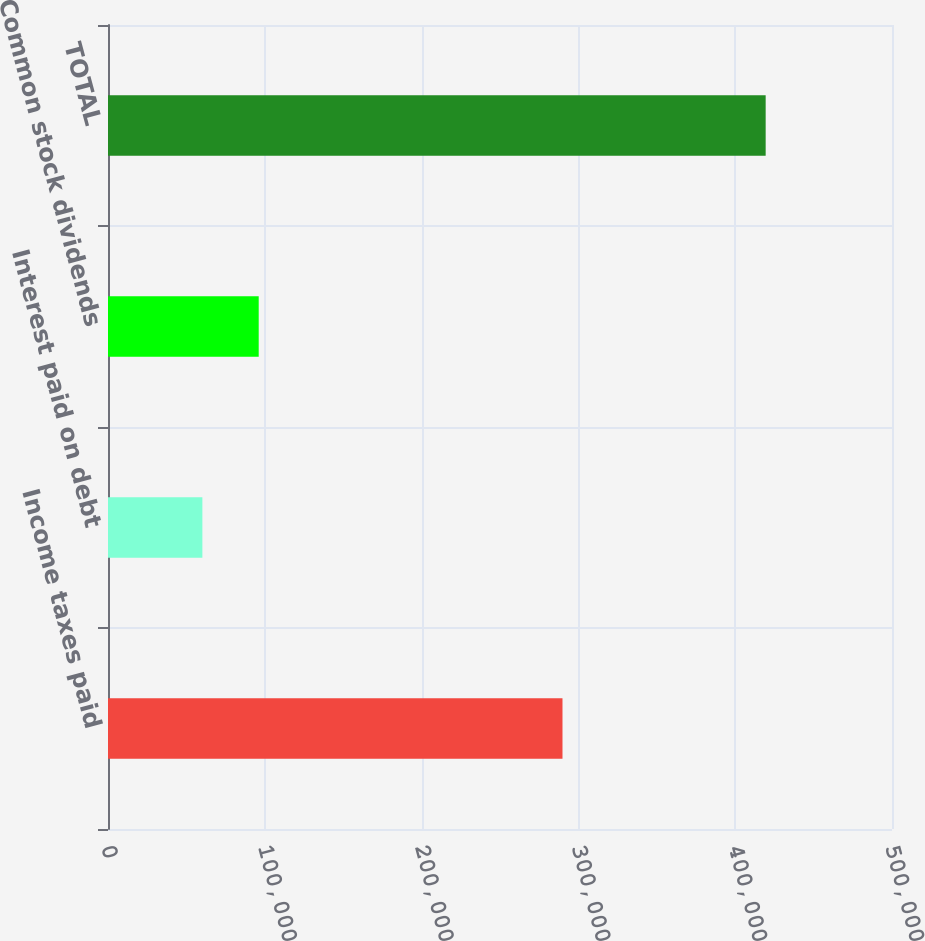Convert chart to OTSL. <chart><loc_0><loc_0><loc_500><loc_500><bar_chart><fcel>Income taxes paid<fcel>Interest paid on debt<fcel>Common stock dividends<fcel>TOTAL<nl><fcel>289850<fcel>60188<fcel>96112.3<fcel>419431<nl></chart> 